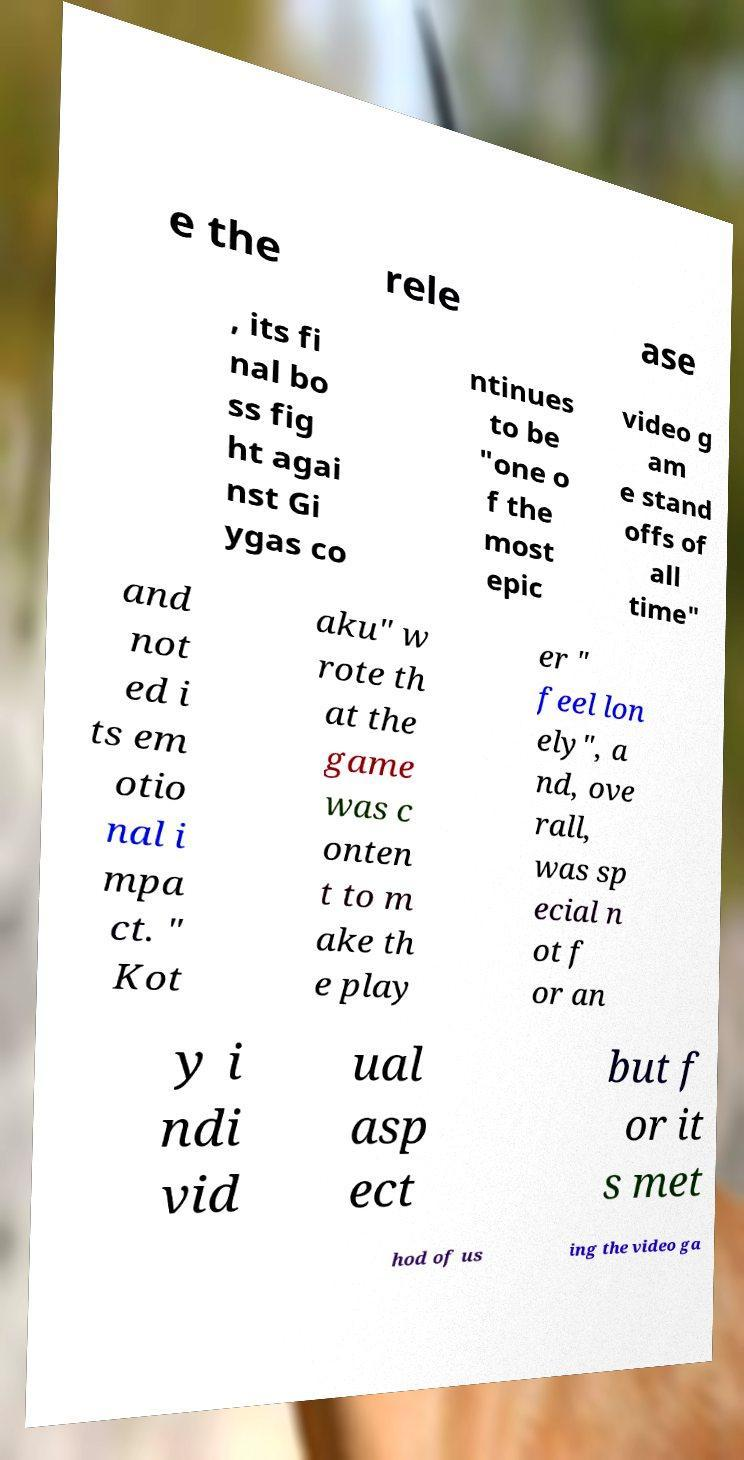Could you assist in decoding the text presented in this image and type it out clearly? e the rele ase , its fi nal bo ss fig ht agai nst Gi ygas co ntinues to be "one o f the most epic video g am e stand offs of all time" and not ed i ts em otio nal i mpa ct. " Kot aku" w rote th at the game was c onten t to m ake th e play er " feel lon ely", a nd, ove rall, was sp ecial n ot f or an y i ndi vid ual asp ect but f or it s met hod of us ing the video ga 